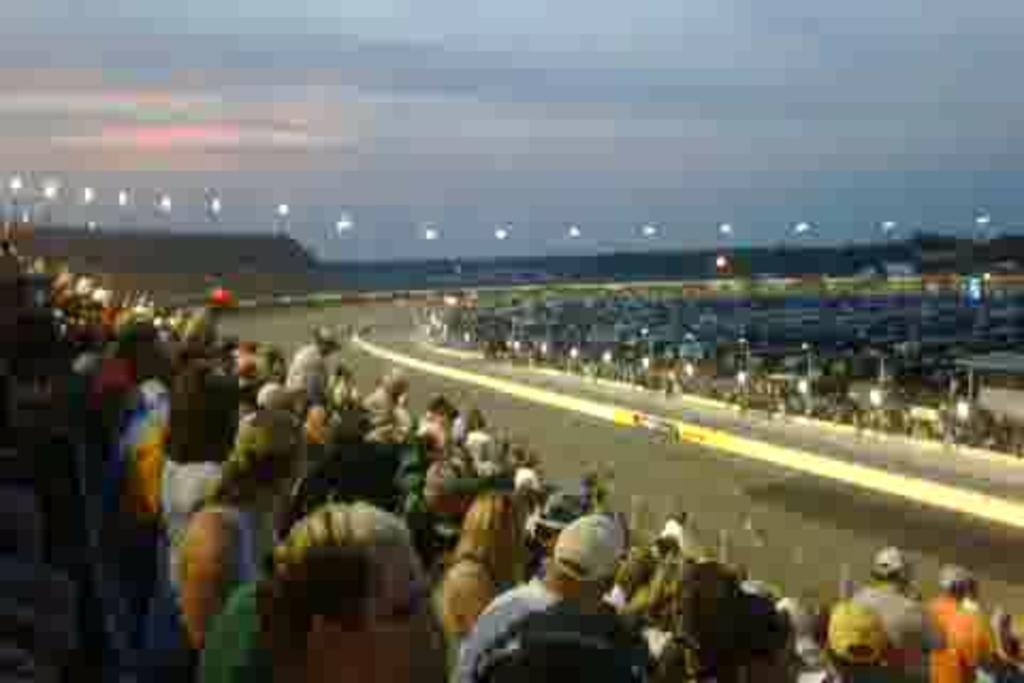Please provide a concise description of this image. In this image in the front there are persons. In the center there is a road and in the background is blurry. 